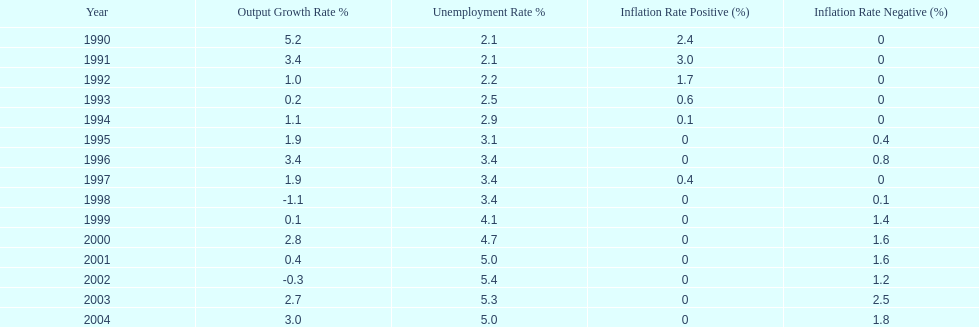When in the 1990's did the inflation rate first become negative? 1995. 